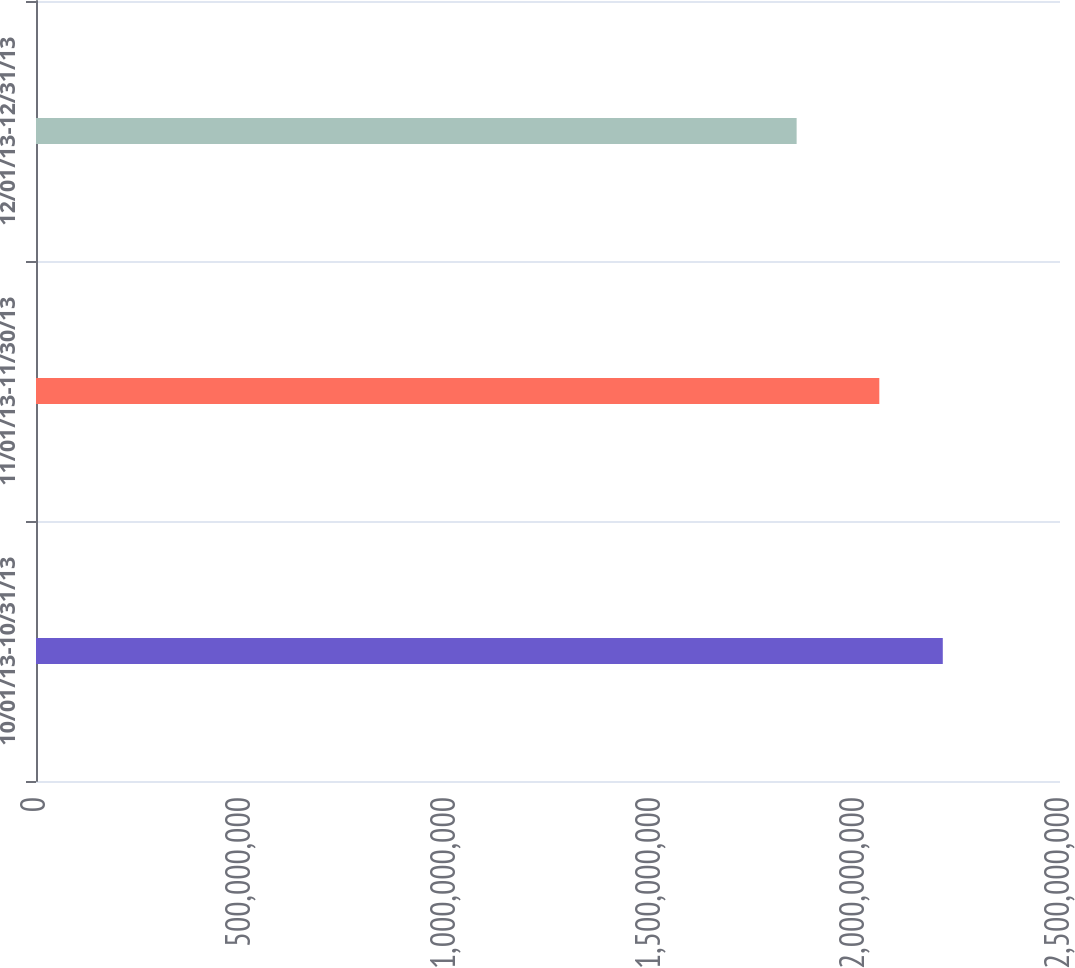Convert chart to OTSL. <chart><loc_0><loc_0><loc_500><loc_500><bar_chart><fcel>10/01/13-10/31/13<fcel>11/01/13-11/30/13<fcel>12/01/13-12/31/13<nl><fcel>2.21386e+09<fcel>2.05888e+09<fcel>1.85702e+09<nl></chart> 